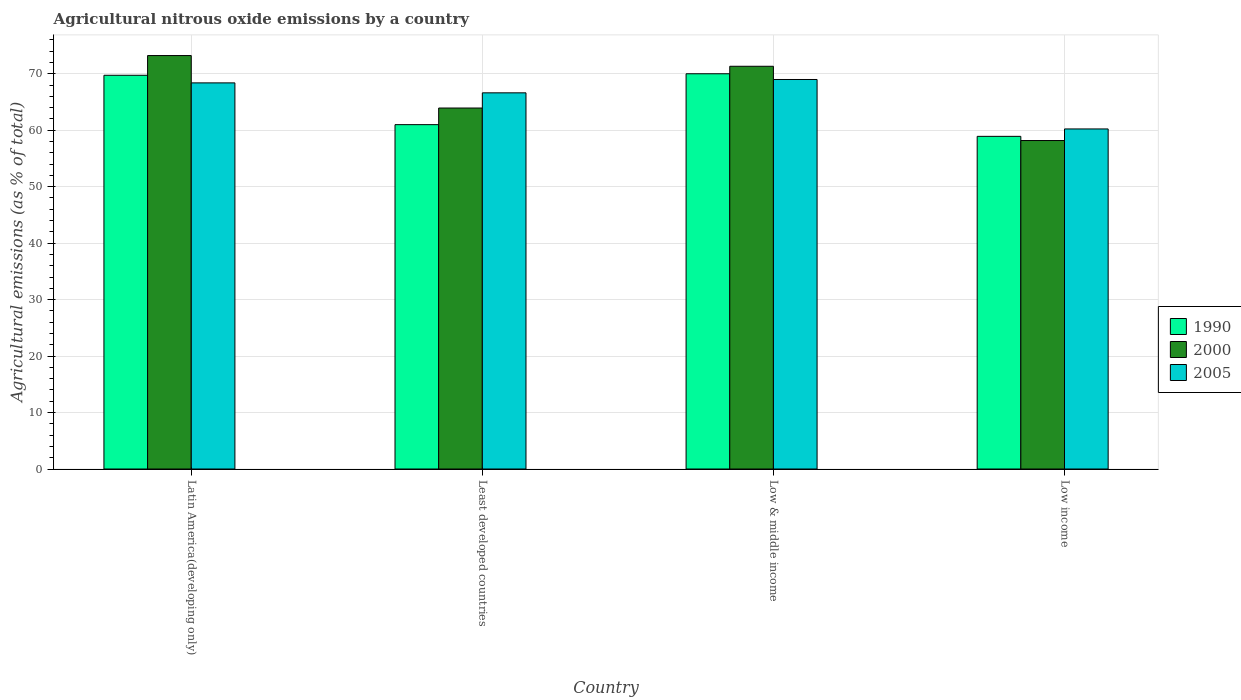How many different coloured bars are there?
Give a very brief answer. 3. How many bars are there on the 3rd tick from the left?
Make the answer very short. 3. What is the label of the 1st group of bars from the left?
Make the answer very short. Latin America(developing only). In how many cases, is the number of bars for a given country not equal to the number of legend labels?
Provide a succinct answer. 0. What is the amount of agricultural nitrous oxide emitted in 2005 in Latin America(developing only)?
Ensure brevity in your answer.  68.38. Across all countries, what is the maximum amount of agricultural nitrous oxide emitted in 1990?
Offer a terse response. 70. Across all countries, what is the minimum amount of agricultural nitrous oxide emitted in 2000?
Offer a terse response. 58.17. In which country was the amount of agricultural nitrous oxide emitted in 2000 maximum?
Offer a terse response. Latin America(developing only). In which country was the amount of agricultural nitrous oxide emitted in 2005 minimum?
Offer a very short reply. Low income. What is the total amount of agricultural nitrous oxide emitted in 2000 in the graph?
Your answer should be very brief. 266.65. What is the difference between the amount of agricultural nitrous oxide emitted in 1990 in Latin America(developing only) and that in Low income?
Make the answer very short. 10.82. What is the difference between the amount of agricultural nitrous oxide emitted in 2000 in Latin America(developing only) and the amount of agricultural nitrous oxide emitted in 2005 in Least developed countries?
Keep it short and to the point. 6.6. What is the average amount of agricultural nitrous oxide emitted in 2005 per country?
Provide a succinct answer. 66.05. What is the difference between the amount of agricultural nitrous oxide emitted of/in 2005 and amount of agricultural nitrous oxide emitted of/in 2000 in Least developed countries?
Ensure brevity in your answer.  2.69. In how many countries, is the amount of agricultural nitrous oxide emitted in 2000 greater than 74 %?
Offer a very short reply. 0. What is the ratio of the amount of agricultural nitrous oxide emitted in 1990 in Low & middle income to that in Low income?
Keep it short and to the point. 1.19. Is the difference between the amount of agricultural nitrous oxide emitted in 2005 in Latin America(developing only) and Low & middle income greater than the difference between the amount of agricultural nitrous oxide emitted in 2000 in Latin America(developing only) and Low & middle income?
Ensure brevity in your answer.  No. What is the difference between the highest and the second highest amount of agricultural nitrous oxide emitted in 1990?
Offer a terse response. -0.27. What is the difference between the highest and the lowest amount of agricultural nitrous oxide emitted in 1990?
Make the answer very short. 11.09. Is the sum of the amount of agricultural nitrous oxide emitted in 2000 in Latin America(developing only) and Low income greater than the maximum amount of agricultural nitrous oxide emitted in 2005 across all countries?
Provide a succinct answer. Yes. What does the 3rd bar from the right in Latin America(developing only) represents?
Ensure brevity in your answer.  1990. Is it the case that in every country, the sum of the amount of agricultural nitrous oxide emitted in 2000 and amount of agricultural nitrous oxide emitted in 1990 is greater than the amount of agricultural nitrous oxide emitted in 2005?
Your answer should be compact. Yes. How many bars are there?
Provide a succinct answer. 12. Are all the bars in the graph horizontal?
Provide a short and direct response. No. How many countries are there in the graph?
Your answer should be very brief. 4. What is the difference between two consecutive major ticks on the Y-axis?
Your answer should be compact. 10. Are the values on the major ticks of Y-axis written in scientific E-notation?
Your answer should be compact. No. Does the graph contain any zero values?
Your response must be concise. No. Does the graph contain grids?
Keep it short and to the point. Yes. Where does the legend appear in the graph?
Ensure brevity in your answer.  Center right. How many legend labels are there?
Provide a succinct answer. 3. What is the title of the graph?
Offer a terse response. Agricultural nitrous oxide emissions by a country. What is the label or title of the Y-axis?
Give a very brief answer. Agricultural emissions (as % of total). What is the Agricultural emissions (as % of total) in 1990 in Latin America(developing only)?
Provide a succinct answer. 69.73. What is the Agricultural emissions (as % of total) of 2000 in Latin America(developing only)?
Give a very brief answer. 73.22. What is the Agricultural emissions (as % of total) in 2005 in Latin America(developing only)?
Offer a terse response. 68.38. What is the Agricultural emissions (as % of total) in 1990 in Least developed countries?
Keep it short and to the point. 60.99. What is the Agricultural emissions (as % of total) in 2000 in Least developed countries?
Offer a terse response. 63.93. What is the Agricultural emissions (as % of total) in 2005 in Least developed countries?
Your response must be concise. 66.62. What is the Agricultural emissions (as % of total) in 1990 in Low & middle income?
Keep it short and to the point. 70. What is the Agricultural emissions (as % of total) of 2000 in Low & middle income?
Your answer should be very brief. 71.32. What is the Agricultural emissions (as % of total) of 2005 in Low & middle income?
Keep it short and to the point. 68.98. What is the Agricultural emissions (as % of total) in 1990 in Low income?
Make the answer very short. 58.91. What is the Agricultural emissions (as % of total) in 2000 in Low income?
Give a very brief answer. 58.17. What is the Agricultural emissions (as % of total) in 2005 in Low income?
Give a very brief answer. 60.22. Across all countries, what is the maximum Agricultural emissions (as % of total) of 1990?
Give a very brief answer. 70. Across all countries, what is the maximum Agricultural emissions (as % of total) of 2000?
Your answer should be compact. 73.22. Across all countries, what is the maximum Agricultural emissions (as % of total) in 2005?
Keep it short and to the point. 68.98. Across all countries, what is the minimum Agricultural emissions (as % of total) in 1990?
Offer a very short reply. 58.91. Across all countries, what is the minimum Agricultural emissions (as % of total) of 2000?
Your answer should be very brief. 58.17. Across all countries, what is the minimum Agricultural emissions (as % of total) of 2005?
Your answer should be compact. 60.22. What is the total Agricultural emissions (as % of total) in 1990 in the graph?
Make the answer very short. 259.62. What is the total Agricultural emissions (as % of total) in 2000 in the graph?
Keep it short and to the point. 266.65. What is the total Agricultural emissions (as % of total) in 2005 in the graph?
Your answer should be compact. 264.21. What is the difference between the Agricultural emissions (as % of total) of 1990 in Latin America(developing only) and that in Least developed countries?
Ensure brevity in your answer.  8.74. What is the difference between the Agricultural emissions (as % of total) in 2000 in Latin America(developing only) and that in Least developed countries?
Offer a terse response. 9.29. What is the difference between the Agricultural emissions (as % of total) of 2005 in Latin America(developing only) and that in Least developed countries?
Ensure brevity in your answer.  1.76. What is the difference between the Agricultural emissions (as % of total) in 1990 in Latin America(developing only) and that in Low & middle income?
Offer a terse response. -0.27. What is the difference between the Agricultural emissions (as % of total) of 2000 in Latin America(developing only) and that in Low & middle income?
Ensure brevity in your answer.  1.9. What is the difference between the Agricultural emissions (as % of total) of 2005 in Latin America(developing only) and that in Low & middle income?
Your answer should be very brief. -0.6. What is the difference between the Agricultural emissions (as % of total) in 1990 in Latin America(developing only) and that in Low income?
Make the answer very short. 10.82. What is the difference between the Agricultural emissions (as % of total) of 2000 in Latin America(developing only) and that in Low income?
Give a very brief answer. 15.05. What is the difference between the Agricultural emissions (as % of total) of 2005 in Latin America(developing only) and that in Low income?
Make the answer very short. 8.16. What is the difference between the Agricultural emissions (as % of total) of 1990 in Least developed countries and that in Low & middle income?
Your answer should be compact. -9.01. What is the difference between the Agricultural emissions (as % of total) of 2000 in Least developed countries and that in Low & middle income?
Your response must be concise. -7.39. What is the difference between the Agricultural emissions (as % of total) of 2005 in Least developed countries and that in Low & middle income?
Keep it short and to the point. -2.36. What is the difference between the Agricultural emissions (as % of total) in 1990 in Least developed countries and that in Low income?
Make the answer very short. 2.07. What is the difference between the Agricultural emissions (as % of total) of 2000 in Least developed countries and that in Low income?
Keep it short and to the point. 5.76. What is the difference between the Agricultural emissions (as % of total) in 2005 in Least developed countries and that in Low income?
Keep it short and to the point. 6.4. What is the difference between the Agricultural emissions (as % of total) in 1990 in Low & middle income and that in Low income?
Make the answer very short. 11.09. What is the difference between the Agricultural emissions (as % of total) in 2000 in Low & middle income and that in Low income?
Your answer should be very brief. 13.15. What is the difference between the Agricultural emissions (as % of total) in 2005 in Low & middle income and that in Low income?
Offer a terse response. 8.76. What is the difference between the Agricultural emissions (as % of total) of 1990 in Latin America(developing only) and the Agricultural emissions (as % of total) of 2000 in Least developed countries?
Your response must be concise. 5.8. What is the difference between the Agricultural emissions (as % of total) in 1990 in Latin America(developing only) and the Agricultural emissions (as % of total) in 2005 in Least developed countries?
Your answer should be compact. 3.11. What is the difference between the Agricultural emissions (as % of total) of 2000 in Latin America(developing only) and the Agricultural emissions (as % of total) of 2005 in Least developed countries?
Give a very brief answer. 6.6. What is the difference between the Agricultural emissions (as % of total) of 1990 in Latin America(developing only) and the Agricultural emissions (as % of total) of 2000 in Low & middle income?
Offer a very short reply. -1.59. What is the difference between the Agricultural emissions (as % of total) in 1990 in Latin America(developing only) and the Agricultural emissions (as % of total) in 2005 in Low & middle income?
Provide a short and direct response. 0.75. What is the difference between the Agricultural emissions (as % of total) in 2000 in Latin America(developing only) and the Agricultural emissions (as % of total) in 2005 in Low & middle income?
Your answer should be compact. 4.24. What is the difference between the Agricultural emissions (as % of total) in 1990 in Latin America(developing only) and the Agricultural emissions (as % of total) in 2000 in Low income?
Offer a very short reply. 11.56. What is the difference between the Agricultural emissions (as % of total) in 1990 in Latin America(developing only) and the Agricultural emissions (as % of total) in 2005 in Low income?
Ensure brevity in your answer.  9.51. What is the difference between the Agricultural emissions (as % of total) in 2000 in Latin America(developing only) and the Agricultural emissions (as % of total) in 2005 in Low income?
Make the answer very short. 13. What is the difference between the Agricultural emissions (as % of total) of 1990 in Least developed countries and the Agricultural emissions (as % of total) of 2000 in Low & middle income?
Your answer should be compact. -10.34. What is the difference between the Agricultural emissions (as % of total) in 1990 in Least developed countries and the Agricultural emissions (as % of total) in 2005 in Low & middle income?
Give a very brief answer. -8. What is the difference between the Agricultural emissions (as % of total) of 2000 in Least developed countries and the Agricultural emissions (as % of total) of 2005 in Low & middle income?
Provide a succinct answer. -5.05. What is the difference between the Agricultural emissions (as % of total) of 1990 in Least developed countries and the Agricultural emissions (as % of total) of 2000 in Low income?
Keep it short and to the point. 2.81. What is the difference between the Agricultural emissions (as % of total) of 1990 in Least developed countries and the Agricultural emissions (as % of total) of 2005 in Low income?
Keep it short and to the point. 0.76. What is the difference between the Agricultural emissions (as % of total) of 2000 in Least developed countries and the Agricultural emissions (as % of total) of 2005 in Low income?
Give a very brief answer. 3.7. What is the difference between the Agricultural emissions (as % of total) in 1990 in Low & middle income and the Agricultural emissions (as % of total) in 2000 in Low income?
Offer a very short reply. 11.83. What is the difference between the Agricultural emissions (as % of total) in 1990 in Low & middle income and the Agricultural emissions (as % of total) in 2005 in Low income?
Ensure brevity in your answer.  9.77. What is the difference between the Agricultural emissions (as % of total) in 2000 in Low & middle income and the Agricultural emissions (as % of total) in 2005 in Low income?
Give a very brief answer. 11.1. What is the average Agricultural emissions (as % of total) in 1990 per country?
Your answer should be very brief. 64.91. What is the average Agricultural emissions (as % of total) of 2000 per country?
Your response must be concise. 66.66. What is the average Agricultural emissions (as % of total) in 2005 per country?
Offer a very short reply. 66.05. What is the difference between the Agricultural emissions (as % of total) in 1990 and Agricultural emissions (as % of total) in 2000 in Latin America(developing only)?
Provide a succinct answer. -3.49. What is the difference between the Agricultural emissions (as % of total) in 1990 and Agricultural emissions (as % of total) in 2005 in Latin America(developing only)?
Ensure brevity in your answer.  1.35. What is the difference between the Agricultural emissions (as % of total) of 2000 and Agricultural emissions (as % of total) of 2005 in Latin America(developing only)?
Give a very brief answer. 4.84. What is the difference between the Agricultural emissions (as % of total) of 1990 and Agricultural emissions (as % of total) of 2000 in Least developed countries?
Keep it short and to the point. -2.94. What is the difference between the Agricultural emissions (as % of total) of 1990 and Agricultural emissions (as % of total) of 2005 in Least developed countries?
Your answer should be very brief. -5.63. What is the difference between the Agricultural emissions (as % of total) in 2000 and Agricultural emissions (as % of total) in 2005 in Least developed countries?
Your response must be concise. -2.69. What is the difference between the Agricultural emissions (as % of total) in 1990 and Agricultural emissions (as % of total) in 2000 in Low & middle income?
Your response must be concise. -1.33. What is the difference between the Agricultural emissions (as % of total) of 1990 and Agricultural emissions (as % of total) of 2005 in Low & middle income?
Your response must be concise. 1.02. What is the difference between the Agricultural emissions (as % of total) in 2000 and Agricultural emissions (as % of total) in 2005 in Low & middle income?
Provide a succinct answer. 2.34. What is the difference between the Agricultural emissions (as % of total) in 1990 and Agricultural emissions (as % of total) in 2000 in Low income?
Provide a short and direct response. 0.74. What is the difference between the Agricultural emissions (as % of total) in 1990 and Agricultural emissions (as % of total) in 2005 in Low income?
Provide a short and direct response. -1.31. What is the difference between the Agricultural emissions (as % of total) of 2000 and Agricultural emissions (as % of total) of 2005 in Low income?
Provide a short and direct response. -2.05. What is the ratio of the Agricultural emissions (as % of total) of 1990 in Latin America(developing only) to that in Least developed countries?
Provide a short and direct response. 1.14. What is the ratio of the Agricultural emissions (as % of total) in 2000 in Latin America(developing only) to that in Least developed countries?
Provide a succinct answer. 1.15. What is the ratio of the Agricultural emissions (as % of total) of 2005 in Latin America(developing only) to that in Least developed countries?
Your answer should be very brief. 1.03. What is the ratio of the Agricultural emissions (as % of total) of 1990 in Latin America(developing only) to that in Low & middle income?
Offer a very short reply. 1. What is the ratio of the Agricultural emissions (as % of total) of 2000 in Latin America(developing only) to that in Low & middle income?
Provide a short and direct response. 1.03. What is the ratio of the Agricultural emissions (as % of total) in 2005 in Latin America(developing only) to that in Low & middle income?
Ensure brevity in your answer.  0.99. What is the ratio of the Agricultural emissions (as % of total) in 1990 in Latin America(developing only) to that in Low income?
Your response must be concise. 1.18. What is the ratio of the Agricultural emissions (as % of total) of 2000 in Latin America(developing only) to that in Low income?
Offer a very short reply. 1.26. What is the ratio of the Agricultural emissions (as % of total) in 2005 in Latin America(developing only) to that in Low income?
Offer a terse response. 1.14. What is the ratio of the Agricultural emissions (as % of total) of 1990 in Least developed countries to that in Low & middle income?
Your answer should be compact. 0.87. What is the ratio of the Agricultural emissions (as % of total) in 2000 in Least developed countries to that in Low & middle income?
Keep it short and to the point. 0.9. What is the ratio of the Agricultural emissions (as % of total) of 2005 in Least developed countries to that in Low & middle income?
Give a very brief answer. 0.97. What is the ratio of the Agricultural emissions (as % of total) in 1990 in Least developed countries to that in Low income?
Keep it short and to the point. 1.04. What is the ratio of the Agricultural emissions (as % of total) in 2000 in Least developed countries to that in Low income?
Provide a short and direct response. 1.1. What is the ratio of the Agricultural emissions (as % of total) of 2005 in Least developed countries to that in Low income?
Offer a terse response. 1.11. What is the ratio of the Agricultural emissions (as % of total) of 1990 in Low & middle income to that in Low income?
Make the answer very short. 1.19. What is the ratio of the Agricultural emissions (as % of total) of 2000 in Low & middle income to that in Low income?
Provide a short and direct response. 1.23. What is the ratio of the Agricultural emissions (as % of total) in 2005 in Low & middle income to that in Low income?
Keep it short and to the point. 1.15. What is the difference between the highest and the second highest Agricultural emissions (as % of total) in 1990?
Provide a succinct answer. 0.27. What is the difference between the highest and the second highest Agricultural emissions (as % of total) of 2000?
Give a very brief answer. 1.9. What is the difference between the highest and the second highest Agricultural emissions (as % of total) in 2005?
Offer a very short reply. 0.6. What is the difference between the highest and the lowest Agricultural emissions (as % of total) of 1990?
Make the answer very short. 11.09. What is the difference between the highest and the lowest Agricultural emissions (as % of total) in 2000?
Make the answer very short. 15.05. What is the difference between the highest and the lowest Agricultural emissions (as % of total) in 2005?
Offer a very short reply. 8.76. 